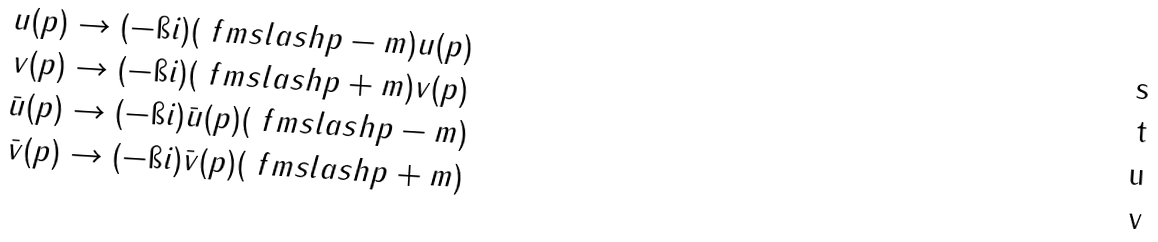Convert formula to latex. <formula><loc_0><loc_0><loc_500><loc_500>u ( p ) & \to ( - \i i ) ( \ f m s l a s h p - m ) u ( p ) \\ v ( p ) & \to ( - \i i ) ( \ f m s l a s h p + m ) v ( p ) \\ \bar { u } ( p ) & \to ( - \i i ) \bar { u } ( p ) ( \ f m s l a s h p - m ) \\ \bar { v } ( p ) & \to ( - \i i ) \bar { v } ( p ) ( \ f m s l a s h p + m )</formula> 